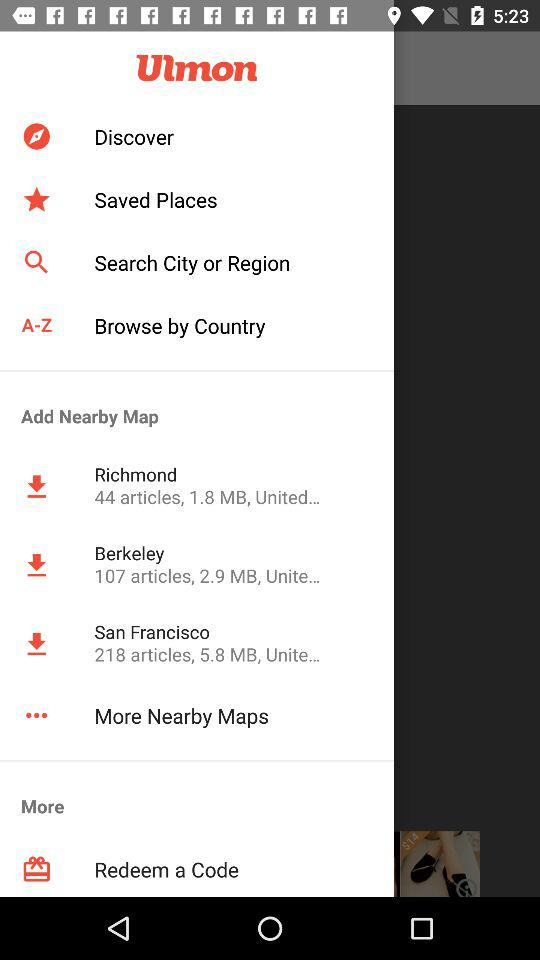What is the size of the "Berkeley" map in MB? The size of the "Berkeley" map is 2.9 MB. 